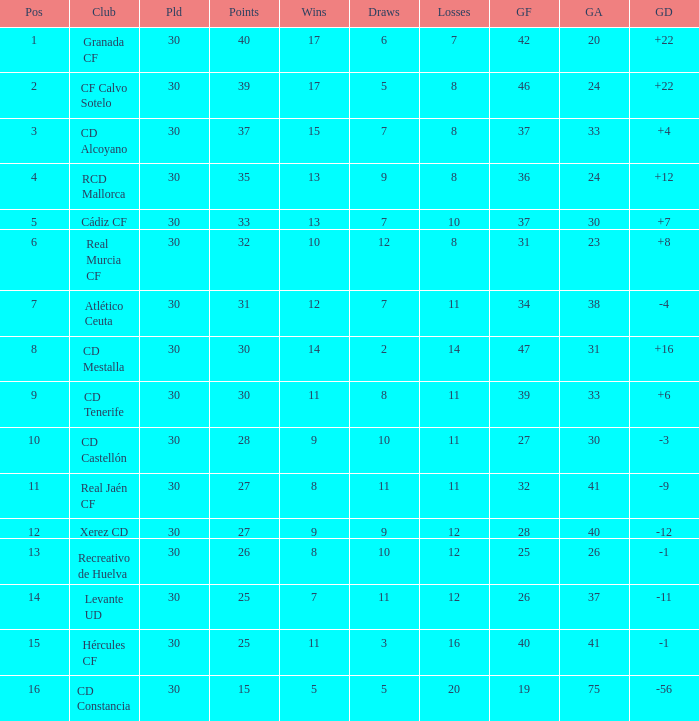How many Wins have Goals against smaller than 30, and Goals for larger than 25, and Draws larger than 5? 3.0. 